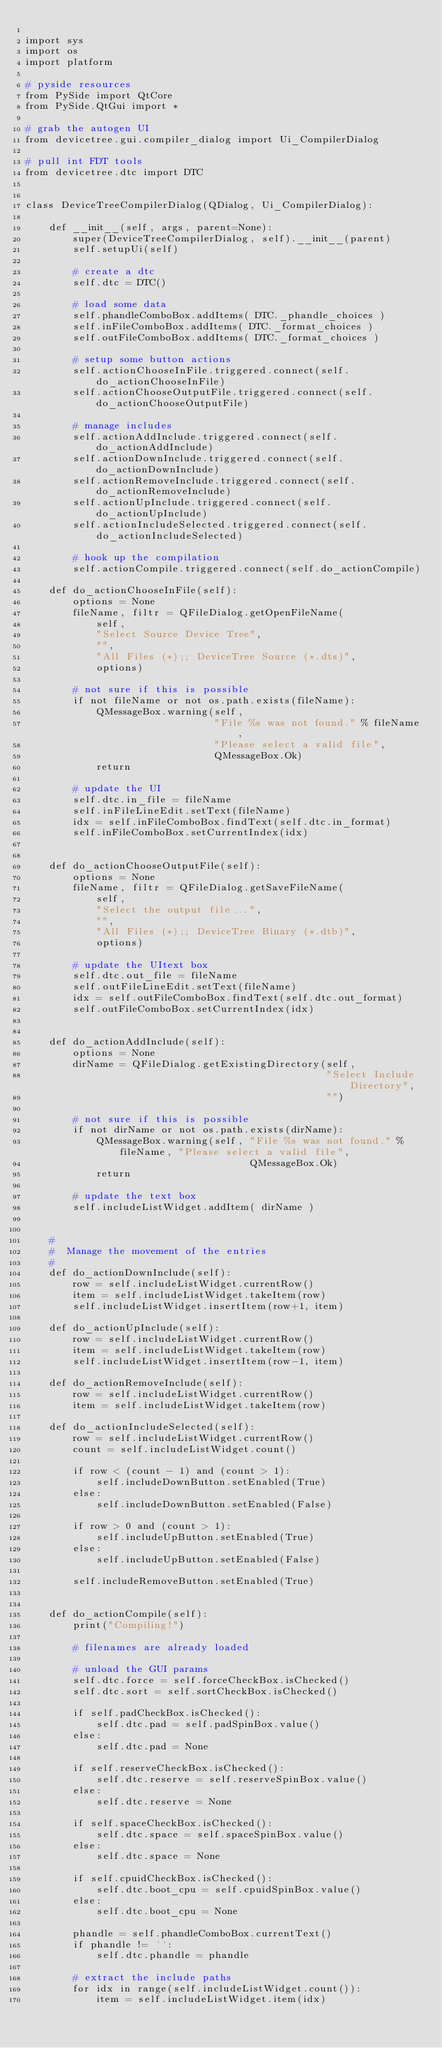<code> <loc_0><loc_0><loc_500><loc_500><_Python_>
import sys
import os
import platform

# pyside resources
from PySide import QtCore
from PySide.QtGui import *

# grab the autogen UI
from devicetree.gui.compiler_dialog import Ui_CompilerDialog

# pull int FDT tools
from devicetree.dtc import DTC


class DeviceTreeCompilerDialog(QDialog, Ui_CompilerDialog):
    
    def __init__(self, args, parent=None):
        super(DeviceTreeCompilerDialog, self).__init__(parent)
        self.setupUi(self)

        # create a dtc
        self.dtc = DTC()

        # load some data
        self.phandleComboBox.addItems( DTC._phandle_choices )
        self.inFileComboBox.addItems( DTC._format_choices )
        self.outFileComboBox.addItems( DTC._format_choices )

        # setup some button actions
        self.actionChooseInFile.triggered.connect(self.do_actionChooseInFile)
        self.actionChooseOutputFile.triggered.connect(self.do_actionChooseOutputFile)

        # manage includes
        self.actionAddInclude.triggered.connect(self.do_actionAddInclude)
        self.actionDownInclude.triggered.connect(self.do_actionDownInclude)
        self.actionRemoveInclude.triggered.connect(self.do_actionRemoveInclude)
        self.actionUpInclude.triggered.connect(self.do_actionUpInclude)
        self.actionIncludeSelected.triggered.connect(self.do_actionIncludeSelected)

        # hook up the compilation
        self.actionCompile.triggered.connect(self.do_actionCompile)
        
    def do_actionChooseInFile(self):
        options = None
        fileName, filtr = QFileDialog.getOpenFileName(
            self,
            "Select Source Device Tree",
            "",
            "All Files (*);; DeviceTree Source (*.dts)",
            options)

        # not sure if this is possible
        if not fileName or not os.path.exists(fileName):
            QMessageBox.warning(self,
                                "File %s was not found." % fileName,
                                "Please select a valid file",
                                QMessageBox.Ok)
            return

        # update the UI
        self.dtc.in_file = fileName
        self.inFileLineEdit.setText(fileName)
        idx = self.inFileComboBox.findText(self.dtc.in_format)
        self.inFileComboBox.setCurrentIndex(idx)
        

    def do_actionChooseOutputFile(self):
        options = None
        fileName, filtr = QFileDialog.getSaveFileName(
            self,
            "Select the output file...",
            "",
            "All Files (*);; DeviceTree Binary (*.dtb)",
            options)

        # update the UItext box
        self.dtc.out_file = fileName
        self.outFileLineEdit.setText(fileName)
        idx = self.outFileComboBox.findText(self.dtc.out_format)
        self.outFileComboBox.setCurrentIndex(idx)


    def do_actionAddInclude(self):
        options = None
        dirName = QFileDialog.getExistingDirectory(self,
                                                   "Select Include Directory",
                                                   "")

        # not sure if this is possible
        if not dirName or not os.path.exists(dirName):
            QMessageBox.warning(self, "File %s was not found." % fileName, "Please select a valid file",
                                      QMessageBox.Ok)
            return

        # update the text box
        self.includeListWidget.addItem( dirName )
        

    #
    #  Manage the movement of the entries
    #
    def do_actionDownInclude(self):
        row = self.includeListWidget.currentRow()
        item = self.includeListWidget.takeItem(row)
        self.includeListWidget.insertItem(row+1, item)

    def do_actionUpInclude(self):
        row = self.includeListWidget.currentRow()
        item = self.includeListWidget.takeItem(row)
        self.includeListWidget.insertItem(row-1, item)

    def do_actionRemoveInclude(self):
        row = self.includeListWidget.currentRow()
        item = self.includeListWidget.takeItem(row)
        
    def do_actionIncludeSelected(self):
        row = self.includeListWidget.currentRow()
        count = self.includeListWidget.count()

        if row < (count - 1) and (count > 1):
            self.includeDownButton.setEnabled(True)
        else:
            self.includeDownButton.setEnabled(False)
            
        if row > 0 and (count > 1):
            self.includeUpButton.setEnabled(True)
        else:
            self.includeUpButton.setEnabled(False)

        self.includeRemoveButton.setEnabled(True)


    def do_actionCompile(self):
        print("Compiling!")

        # filenames are already loaded

        # unload the GUI params
        self.dtc.force = self.forceCheckBox.isChecked()
        self.dtc.sort = self.sortCheckBox.isChecked()

        if self.padCheckBox.isChecked():
            self.dtc.pad = self.padSpinBox.value()
        else:
            self.dtc.pad = None

        if self.reserveCheckBox.isChecked():
            self.dtc.reserve = self.reserveSpinBox.value()
        else:
            self.dtc.reserve = None

        if self.spaceCheckBox.isChecked():
            self.dtc.space = self.spaceSpinBox.value()
        else:
            self.dtc.space = None

        if self.cpuidCheckBox.isChecked():
            self.dtc.boot_cpu = self.cpuidSpinBox.value()
        else:
            self.dtc.boot_cpu = None

        phandle = self.phandleComboBox.currentText()
        if phandle != '':
            self.dtc.phandle = phandle

        # extract the include paths
        for idx in range(self.includeListWidget.count()):
            item = self.includeListWidget.item(idx)</code> 